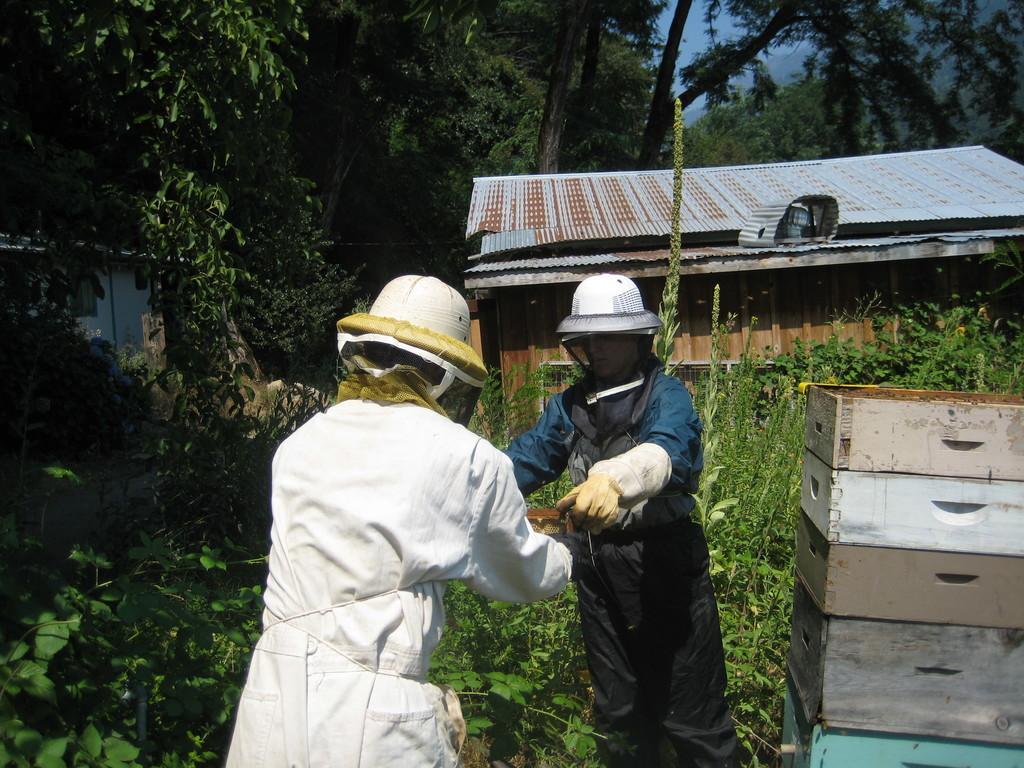Can you describe this image briefly? In the image there are two people, both of them are holding some objects with their hands and on the right side there are wooden boxes kept one upon another. Around the people there are plants and there is a wooden construction covered with metal sheets and around that there are many trees. 